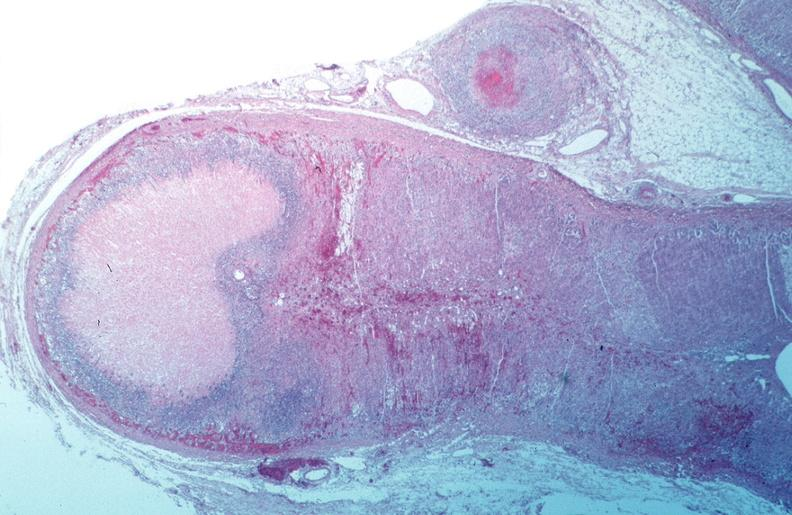s cardiovascular present?
Answer the question using a single word or phrase. Yes 